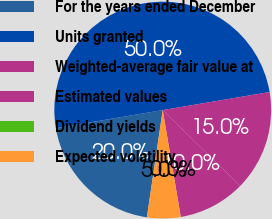<chart> <loc_0><loc_0><loc_500><loc_500><pie_chart><fcel>For the years ended December<fcel>Units granted<fcel>Weighted-average fair value at<fcel>Estimated values<fcel>Dividend yields<fcel>Expected volatility<nl><fcel>20.0%<fcel>50.0%<fcel>15.0%<fcel>10.0%<fcel>0.0%<fcel>5.0%<nl></chart> 